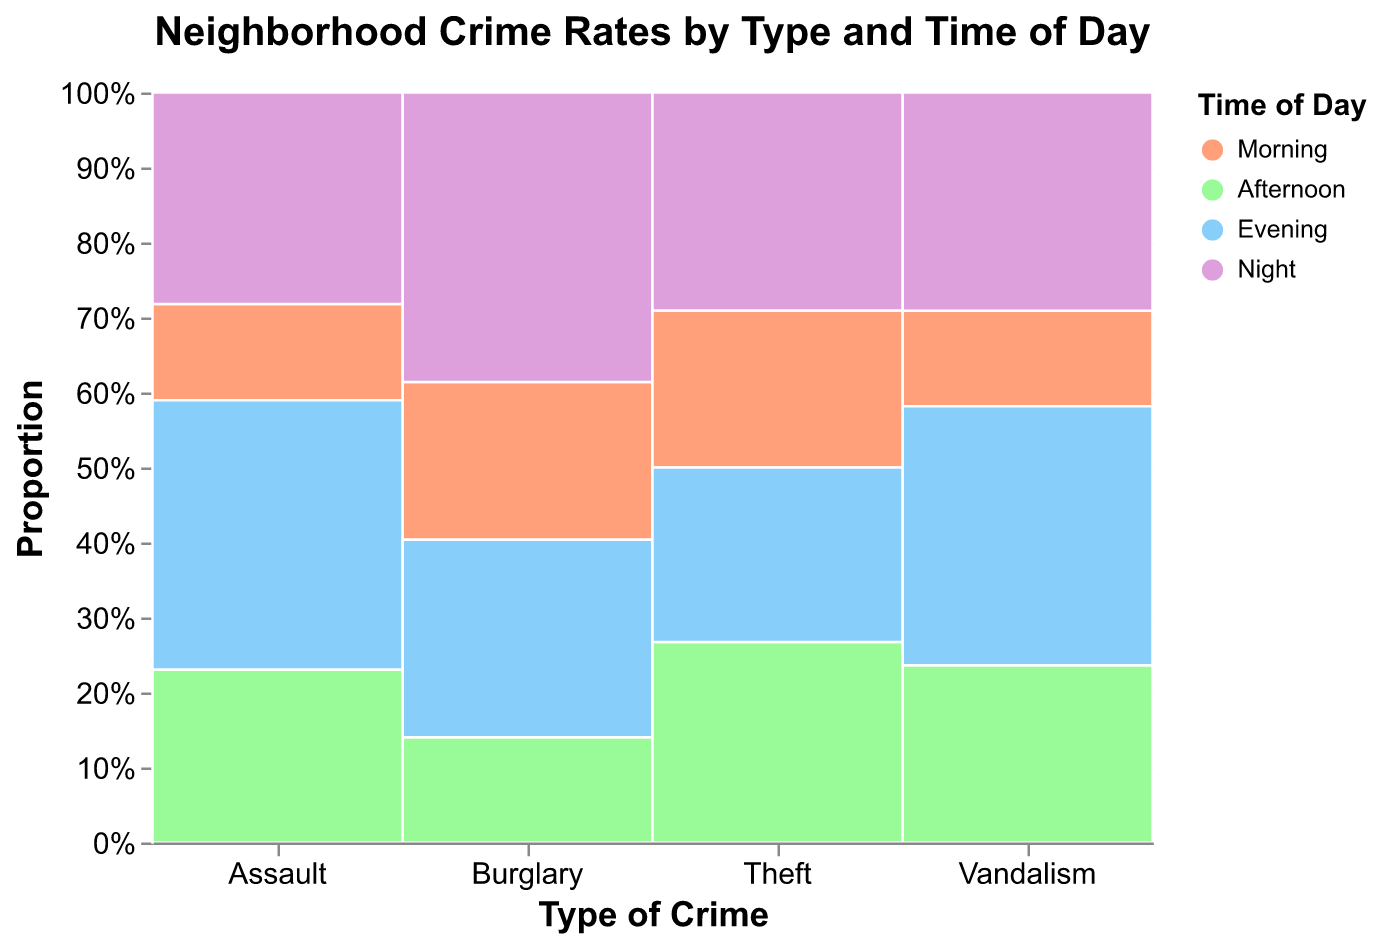What's the title of the figure? The title is displayed at the top of the figure in bold and larger font.
Answer: Neighborhood Crime Rates by Type and Time of Day What colors represent the different times of day? The legend on the figure assigns colors to "Morning", "Afternoon", "Evening", and "Night". Morning is #FFA07A (light coral), Afternoon is #98FB98 (pale green), Evening is #87CEFA (light sky blue), and Night is #DDA0DD (plum).
Answer: Morning: light coral, Afternoon: pale green, Evening: light sky blue, Night: plum How many types of crimes are represented in the plot? The x-axis lists the distinct categories for crime types, which include Burglary, Vandalism, Assault, and Theft.
Answer: 4 Which time of day has the highest frequency of crime overall? The sum of frequencies for each "Time of Day" across all crimes needs to be tallied.
Answer: Night What crime type is most frequent at night? Observing the tallest segment under "Night" reveals the crime type with the highest frequency. For "Night", the segment for "Theft" is the tallest.
Answer: Theft What is the total frequency of Burglary throughout all time periods? Adding up frequencies for Burglary during Morning (12), Afternoon (8), Evening (15), and Night (22): 12 + 8 + 15 + 22 = 57.
Answer: 57 Which has a higher frequency in the afternoon: Assault or Vandalism? Comparing the heights of the "Afternoon" segments for Assault and Vandalism shows Vandalism is higher at 13, while Assault is 9.
Answer: Vandalism Between Burglary and Vandalism, which has a more balanced distribution across different times of day? Analyzing how evenly distributed the segments are for each time of day shows if the segments are closer in size. Vandalism (7, 13, 19, 16) has a more balanced distribution compared to Burglary (12, 8, 15, 22).
Answer: Vandalism What proportion of total thefts occur in the evening? The plot's visual height proportion for "Evening" in the "Theft" column relative to other times needs to be calculated. Theft: (18 Morning, 23 Afternoon, 20 Evening, 25 Night), evening is approximately 20 / (18+23+20+25) = 20/86 ≈ 0.23, or 23%.
Answer: 23% Which crime type has the lowest frequency during the morning? Observing the smallest segment within the "Morning" column across all crime types shows that Assault with a value of 5 is the least.
Answer: Assault 